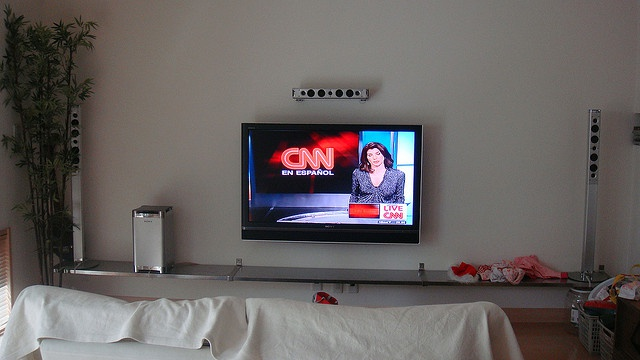Describe the objects in this image and their specific colors. I can see couch in black, darkgray, gray, and lightgray tones, tv in black, lavender, navy, and lightblue tones, and potted plant in black and gray tones in this image. 